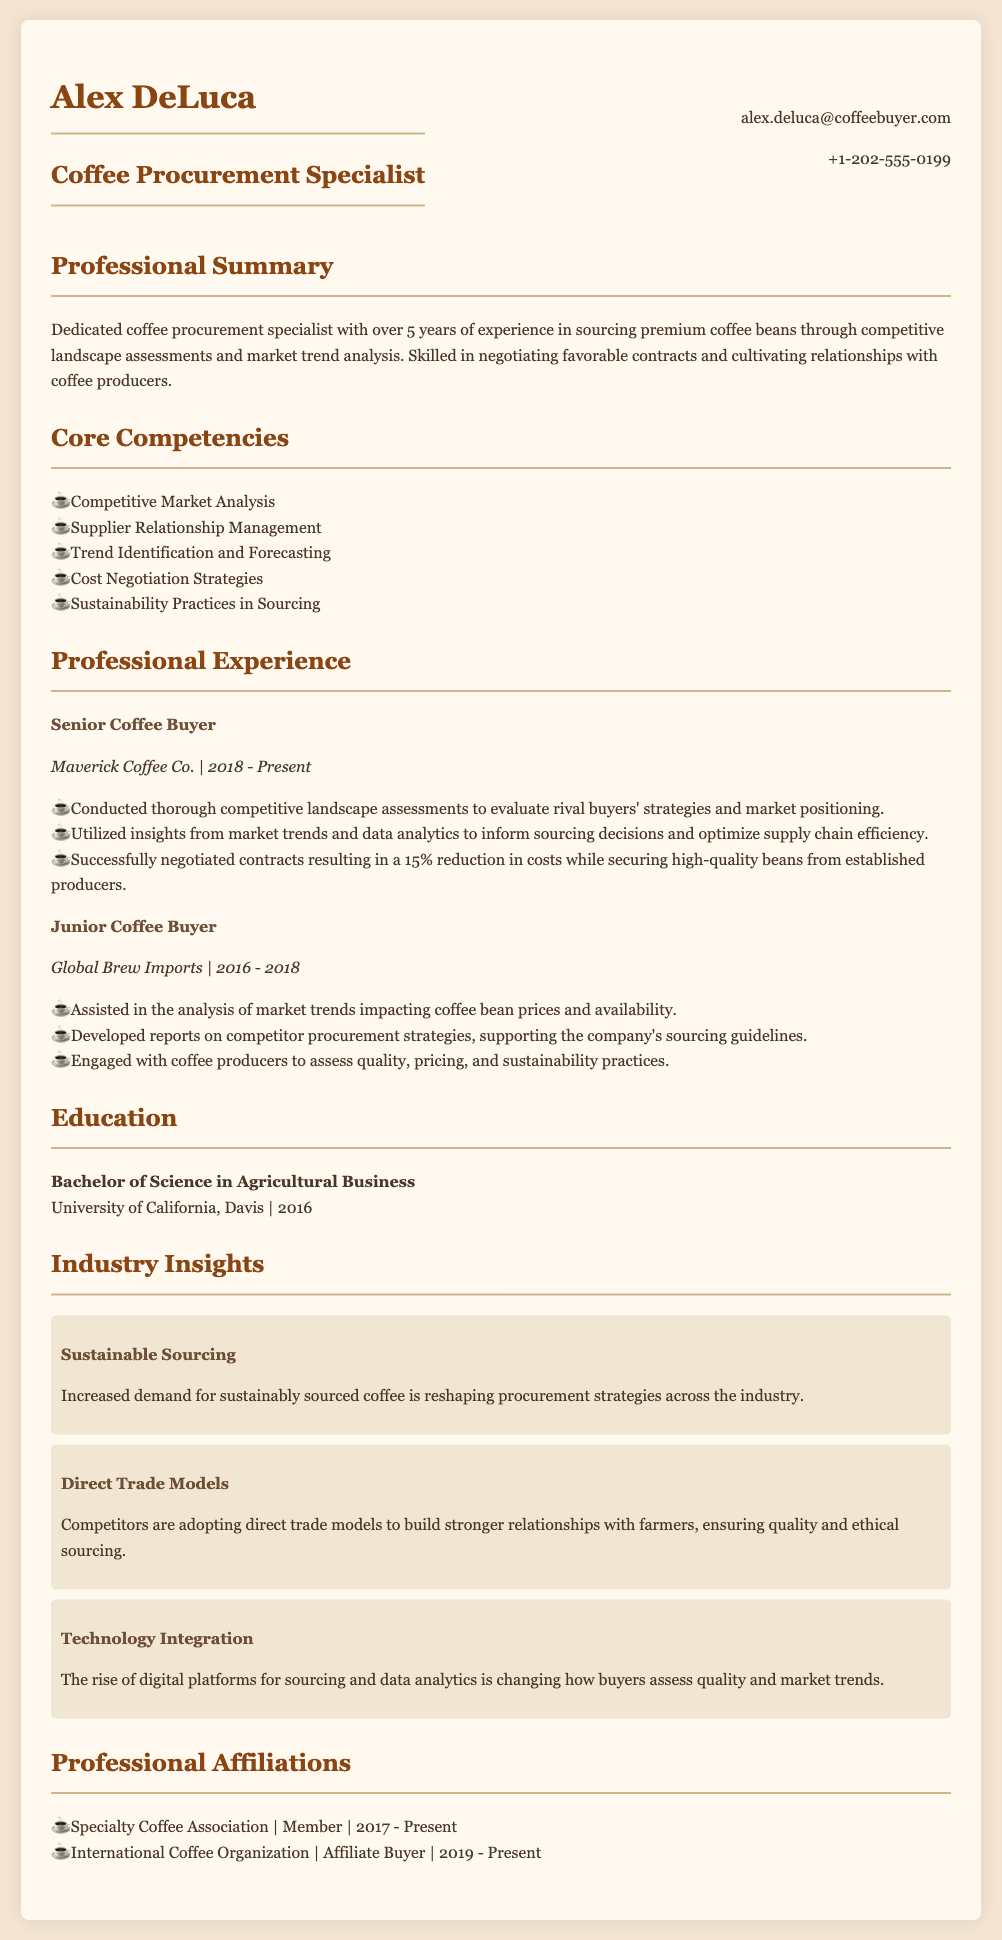what is Alex DeLuca's job title? The job title is mentioned in the header section of the document.
Answer: Coffee Procurement Specialist how many years of experience does Alex have? The professional summary states that Alex has over 5 years of experience.
Answer: 5 years which company did Alex work for as a Junior Coffee Buyer? The document lists the companies where Alex worked, including the position held during that time.
Answer: Global Brew Imports what was the contract cost reduction achieved by Alex at Maverick Coffee Co.? This information is specified in the professional experience section for the Senior Coffee Buyer role.
Answer: 15% which university did Alex attend? The education section provides the name of the university where Alex completed his degree.
Answer: University of California, Davis what trend is increasing alongside the demand for sustainably sourced coffee? The industry insights section discusses recent trends in the coffee procurement market.
Answer: Direct Trade Models when did Alex become a member of the Specialty Coffee Association? The professional affiliations section lists the membership duration.
Answer: 2017 what skill involves "cultivating relationships with coffee producers"? This skill is included in the core competencies section of the CV.
Answer: Supplier Relationship Management 